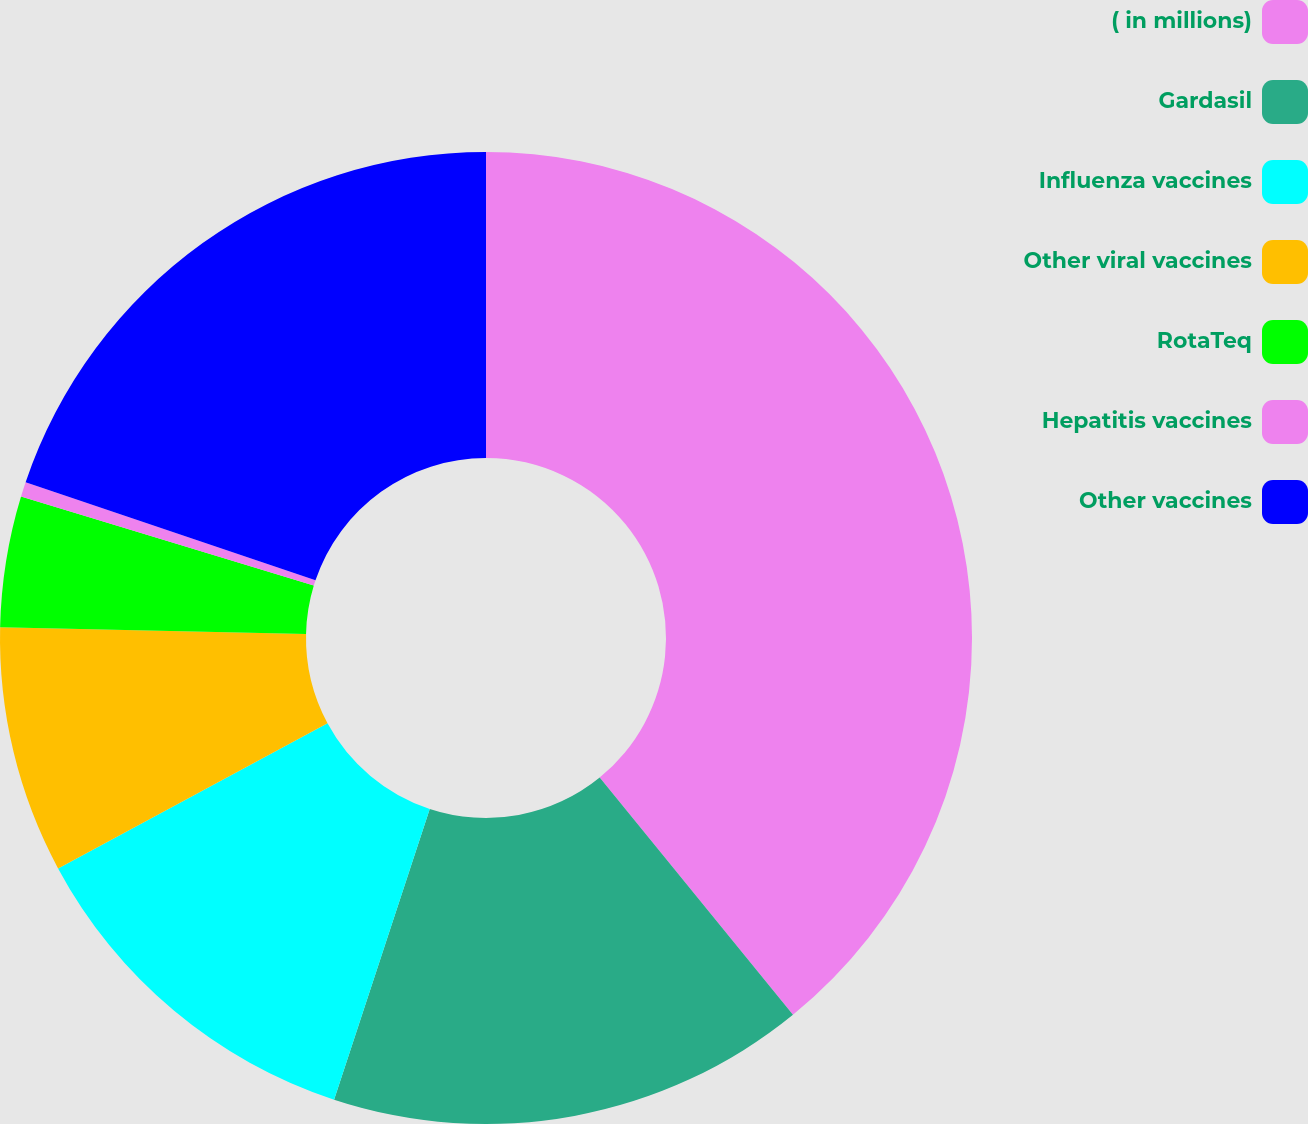Convert chart to OTSL. <chart><loc_0><loc_0><loc_500><loc_500><pie_chart><fcel>( in millions)<fcel>Gardasil<fcel>Influenza vaccines<fcel>Other viral vaccines<fcel>RotaTeq<fcel>Hepatitis vaccines<fcel>Other vaccines<nl><fcel>39.12%<fcel>15.94%<fcel>12.08%<fcel>8.21%<fcel>4.35%<fcel>0.49%<fcel>19.81%<nl></chart> 